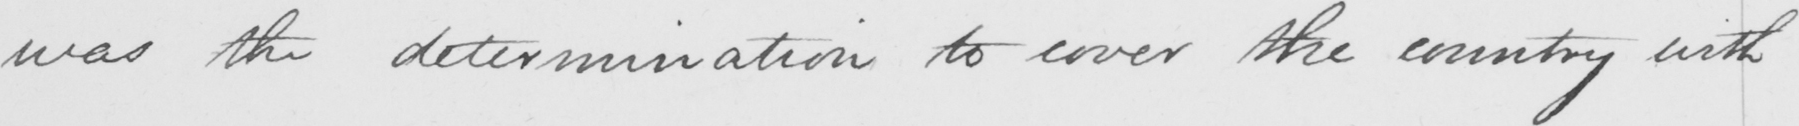Can you tell me what this handwritten text says? was the determination to cover the country with 